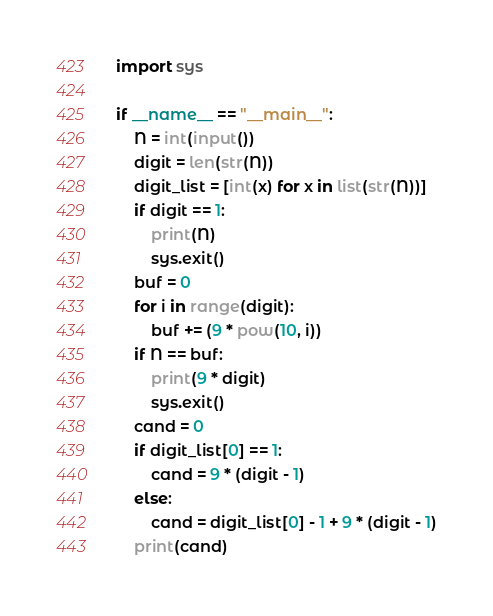Convert code to text. <code><loc_0><loc_0><loc_500><loc_500><_Python_>import sys

if __name__ == "__main__":
    N = int(input())
    digit = len(str(N))
    digit_list = [int(x) for x in list(str(N))]
    if digit == 1:
        print(N)
        sys.exit()
    buf = 0
    for i in range(digit):
        buf += (9 * pow(10, i))
    if N == buf:
        print(9 * digit)
        sys.exit()
    cand = 0
    if digit_list[0] == 1:
        cand = 9 * (digit - 1)
    else:
        cand = digit_list[0] - 1 + 9 * (digit - 1)
    print(cand)</code> 